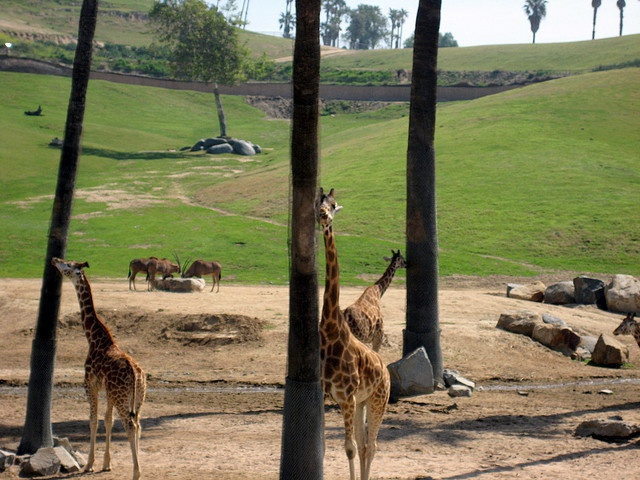Describe the objects in this image and their specific colors. I can see giraffe in darkgreen, black, maroon, and gray tones, giraffe in darkgreen, black, maroon, and gray tones, and giraffe in darkgreen, black, maroon, gray, and tan tones in this image. 